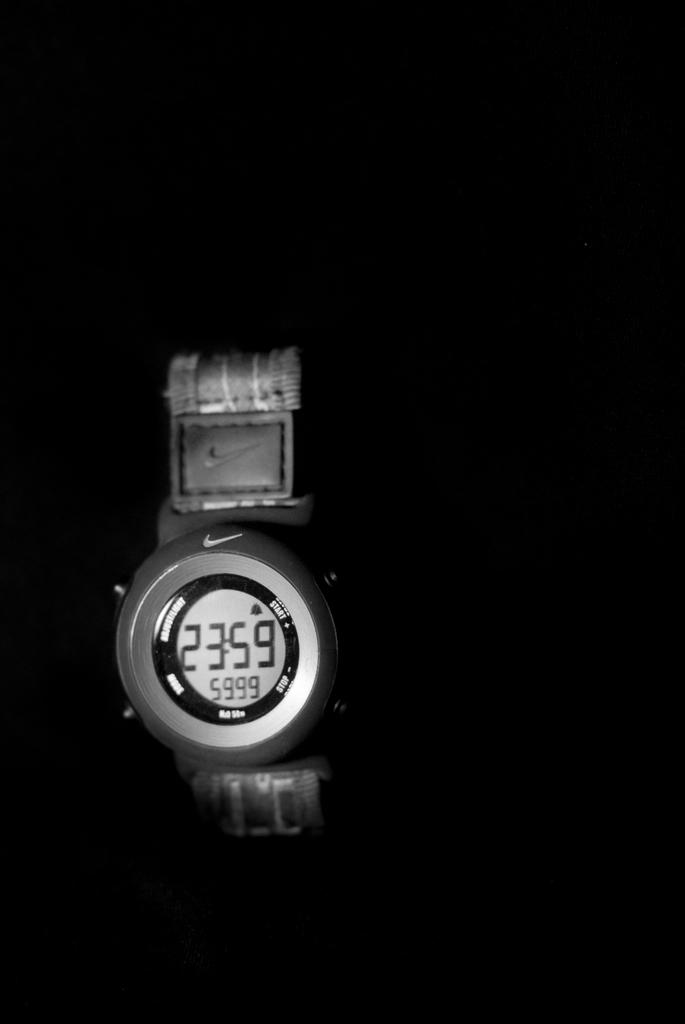<image>
Summarize the visual content of the image. A nike digital sport watch that indicates the time as 23:59. 